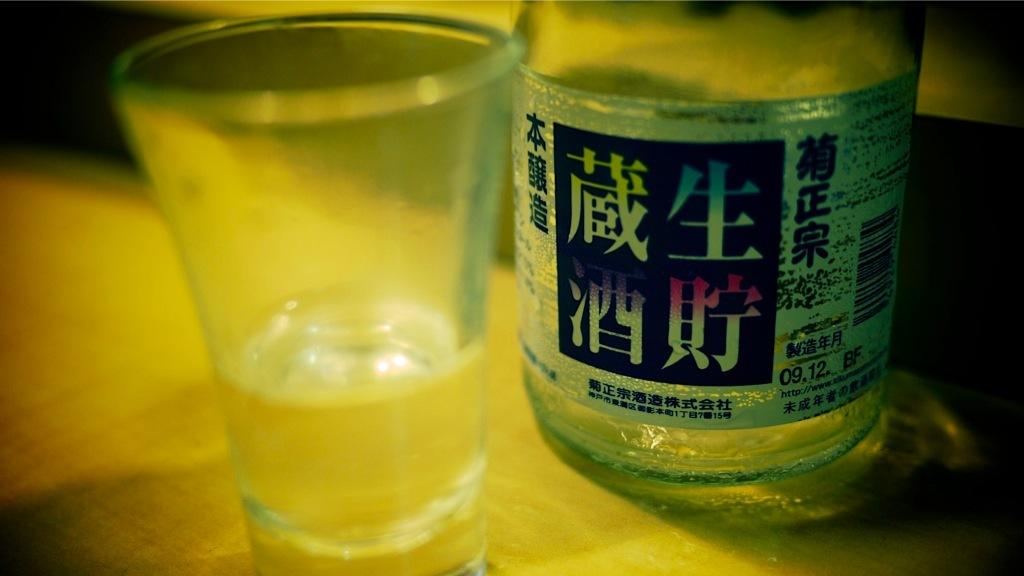<image>
Share a concise interpretation of the image provided. A glass jar with Chinese lettering, which says, "09.12 BF" on its side, sits next to a clear drinking glass. 